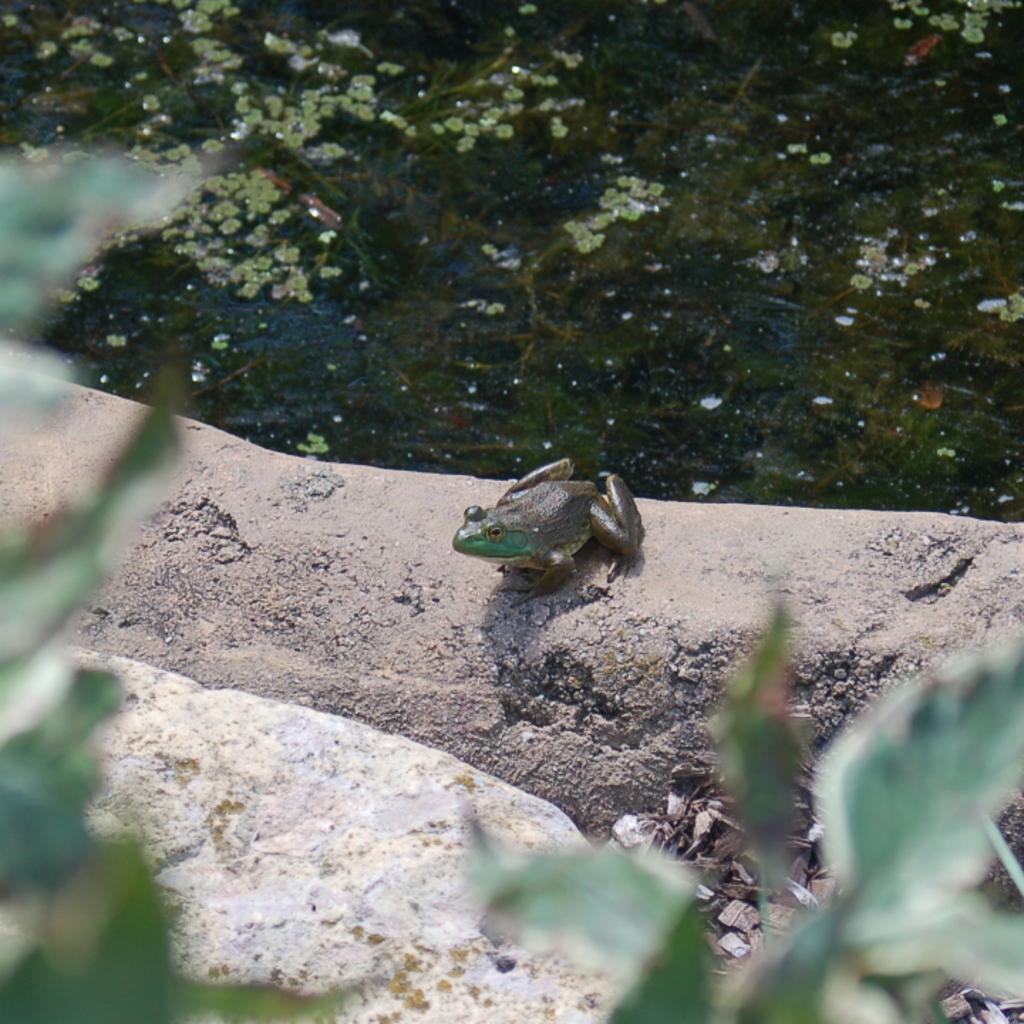In one or two sentences, can you explain what this image depicts? In this image I can see the plant and the rock. To the side of the rock I can see the frog on the ground. In the background I can see the water. 